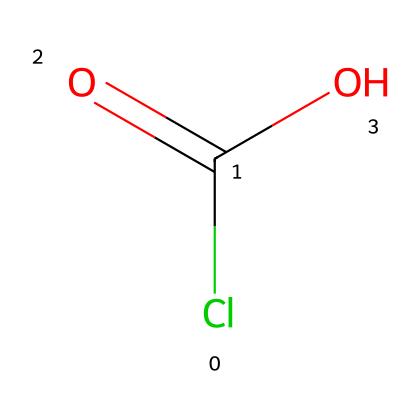What is the molecular formula of this compound? The SMILES representation indicates one chlorine atom (Cl), two oxygen atoms (O), and one carbon atom (C), which gives the molecular formula as ClC(=O)O.
Answer: ClCO2 How many oxygen atoms are present in this compound? From the structure represented in the SMILES notation, we can see there are two 'O' characters, indicating there are two oxygen atoms.
Answer: 2 What type of bonds are present in this molecule? The structure indicates that there are double bonds between the carbon and one oxygen (C=O) and a single bond from the carbon to the hydroxyl group (C-OH), indicating both single and double bonds are present.
Answer: single and double Is this compound an organic acid? The presence of the carboxylic group (-COOH) is evident from the SMILES notation, which classifies it as an organic acid.
Answer: yes What role does chlorine play in this compound? The chlorine attaches to the carbon, affecting the reactivity and properties of the molecule, including its behavior as a cleaning agent.
Answer: reactive group What is the hybridization of the carbon atom in this compound? The carbon atom in this structure is bonded to one chlorine atom, one hydroxyl group, and has a double bond with oxygen, suggesting it has sp2 hybridization due to its geometry.
Answer: sp2 How does the presence of chlorine influence the reactivity of this compound? Chlorine is highly electronegative and, being a halogen, tends to attract electrons, making the compound more reactive, particularly in nucleophilic substitution reactions.
Answer: increases reactivity 